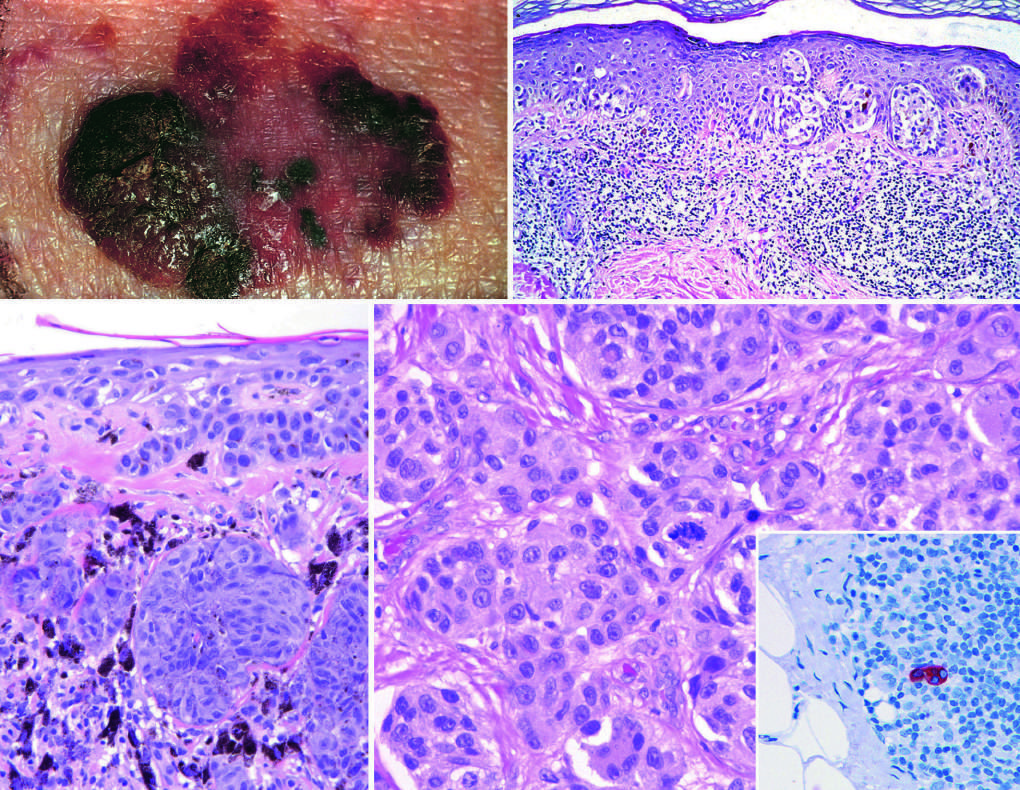what do elevated areas indicate?
Answer the question using a single word or phrase. Dermal invasion 